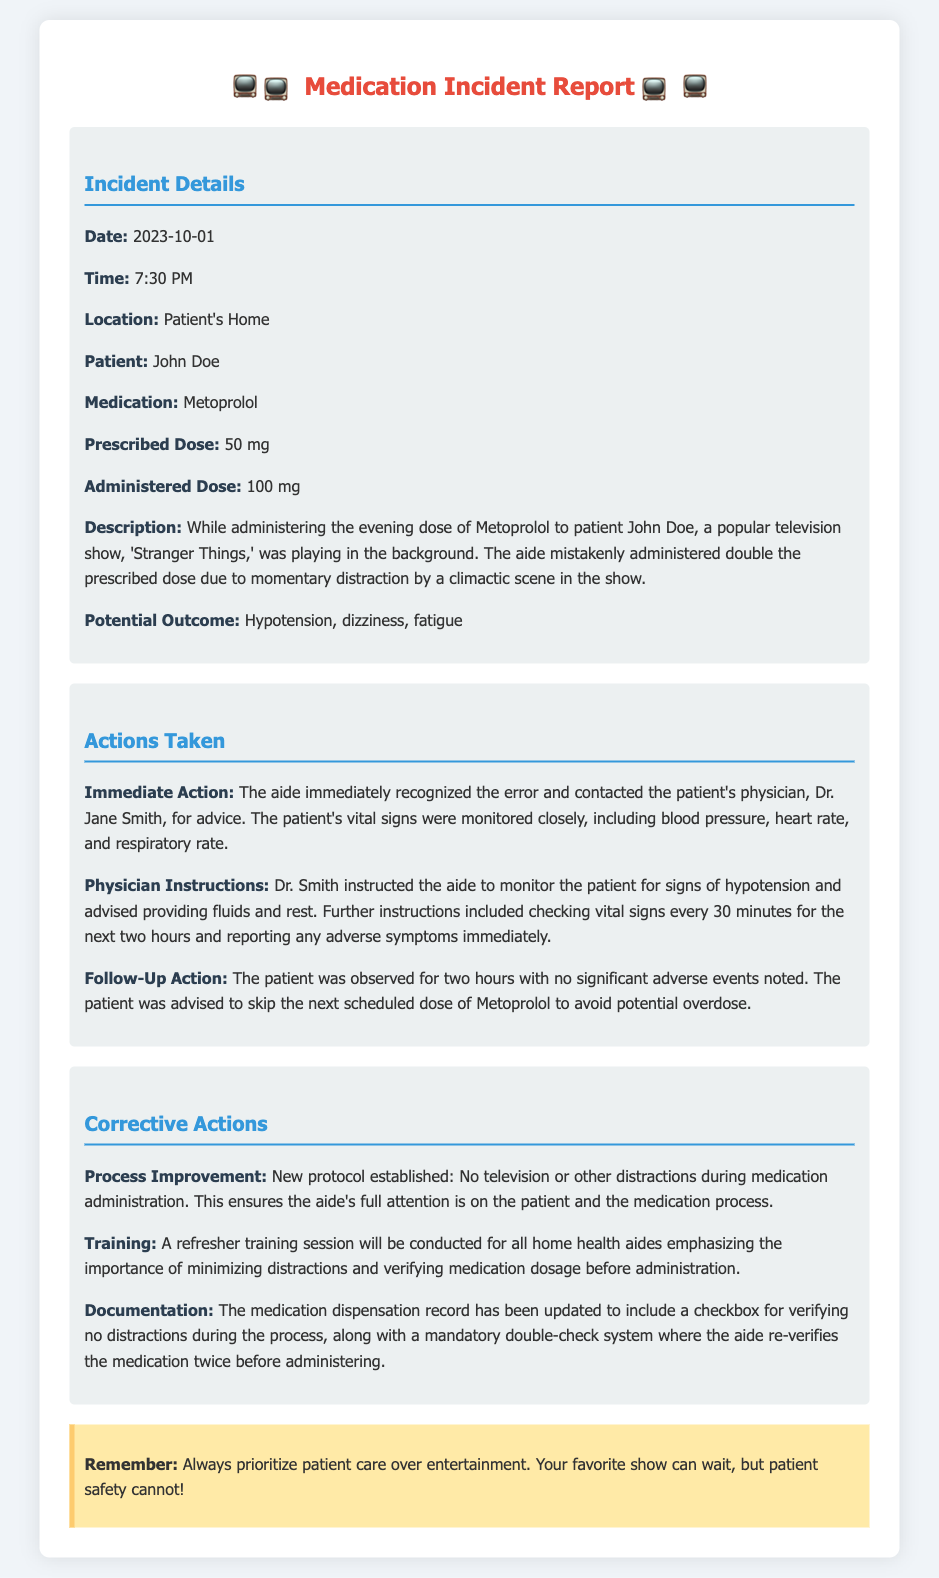What was the date of the incident? The date of the incident is listed in the incident details.
Answer: 2023-10-01 What medication was involved in the error? The medication mentioned in the report is clearly stated in the incident details.
Answer: Metoprolol What was the prescribed dose? The prescribed dose is specified under the incident details section.
Answer: 50 mg What immediate action was taken by the aide? The report explains the immediate action taken after the error was recognized.
Answer: Contacted the patient's physician What was the physician's instruction regarding the monitoring of vital signs? The instructions given by the physician are detailed in the actions taken section of the document.
Answer: Every 30 minutes for the next two hours What new protocol was established after the incident? The corrective actions outline the process improvement established after the error.
Answer: No television or other distractions What training measure is being taken for home health aides? The corrective actions specify what training will be conducted for the aides.
Answer: Refresher training session What potential outcome was noted due to the medication error? The potential outcome is listed in the incident details section.
Answer: Hypotension, dizziness, fatigue What was documented to prevent future errors? The corrective actions mention a specific documentation improvement made for future medication dispensation.
Answer: A checkbox for verifying no distractions 